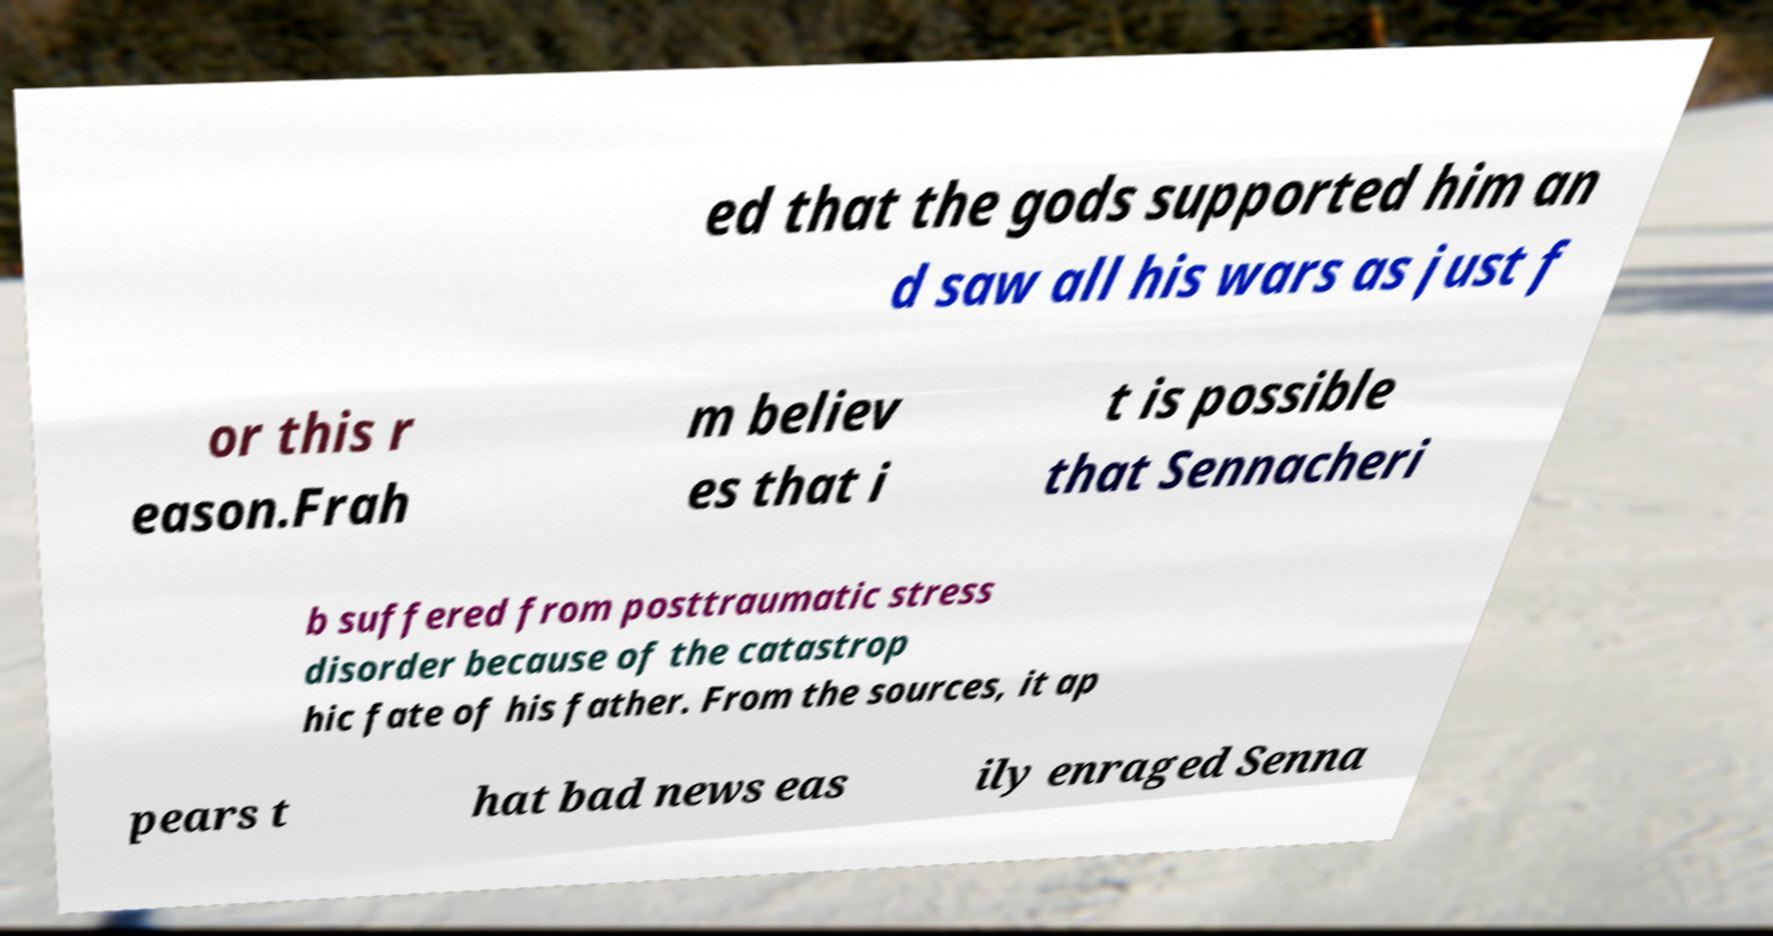Can you accurately transcribe the text from the provided image for me? ed that the gods supported him an d saw all his wars as just f or this r eason.Frah m believ es that i t is possible that Sennacheri b suffered from posttraumatic stress disorder because of the catastrop hic fate of his father. From the sources, it ap pears t hat bad news eas ily enraged Senna 